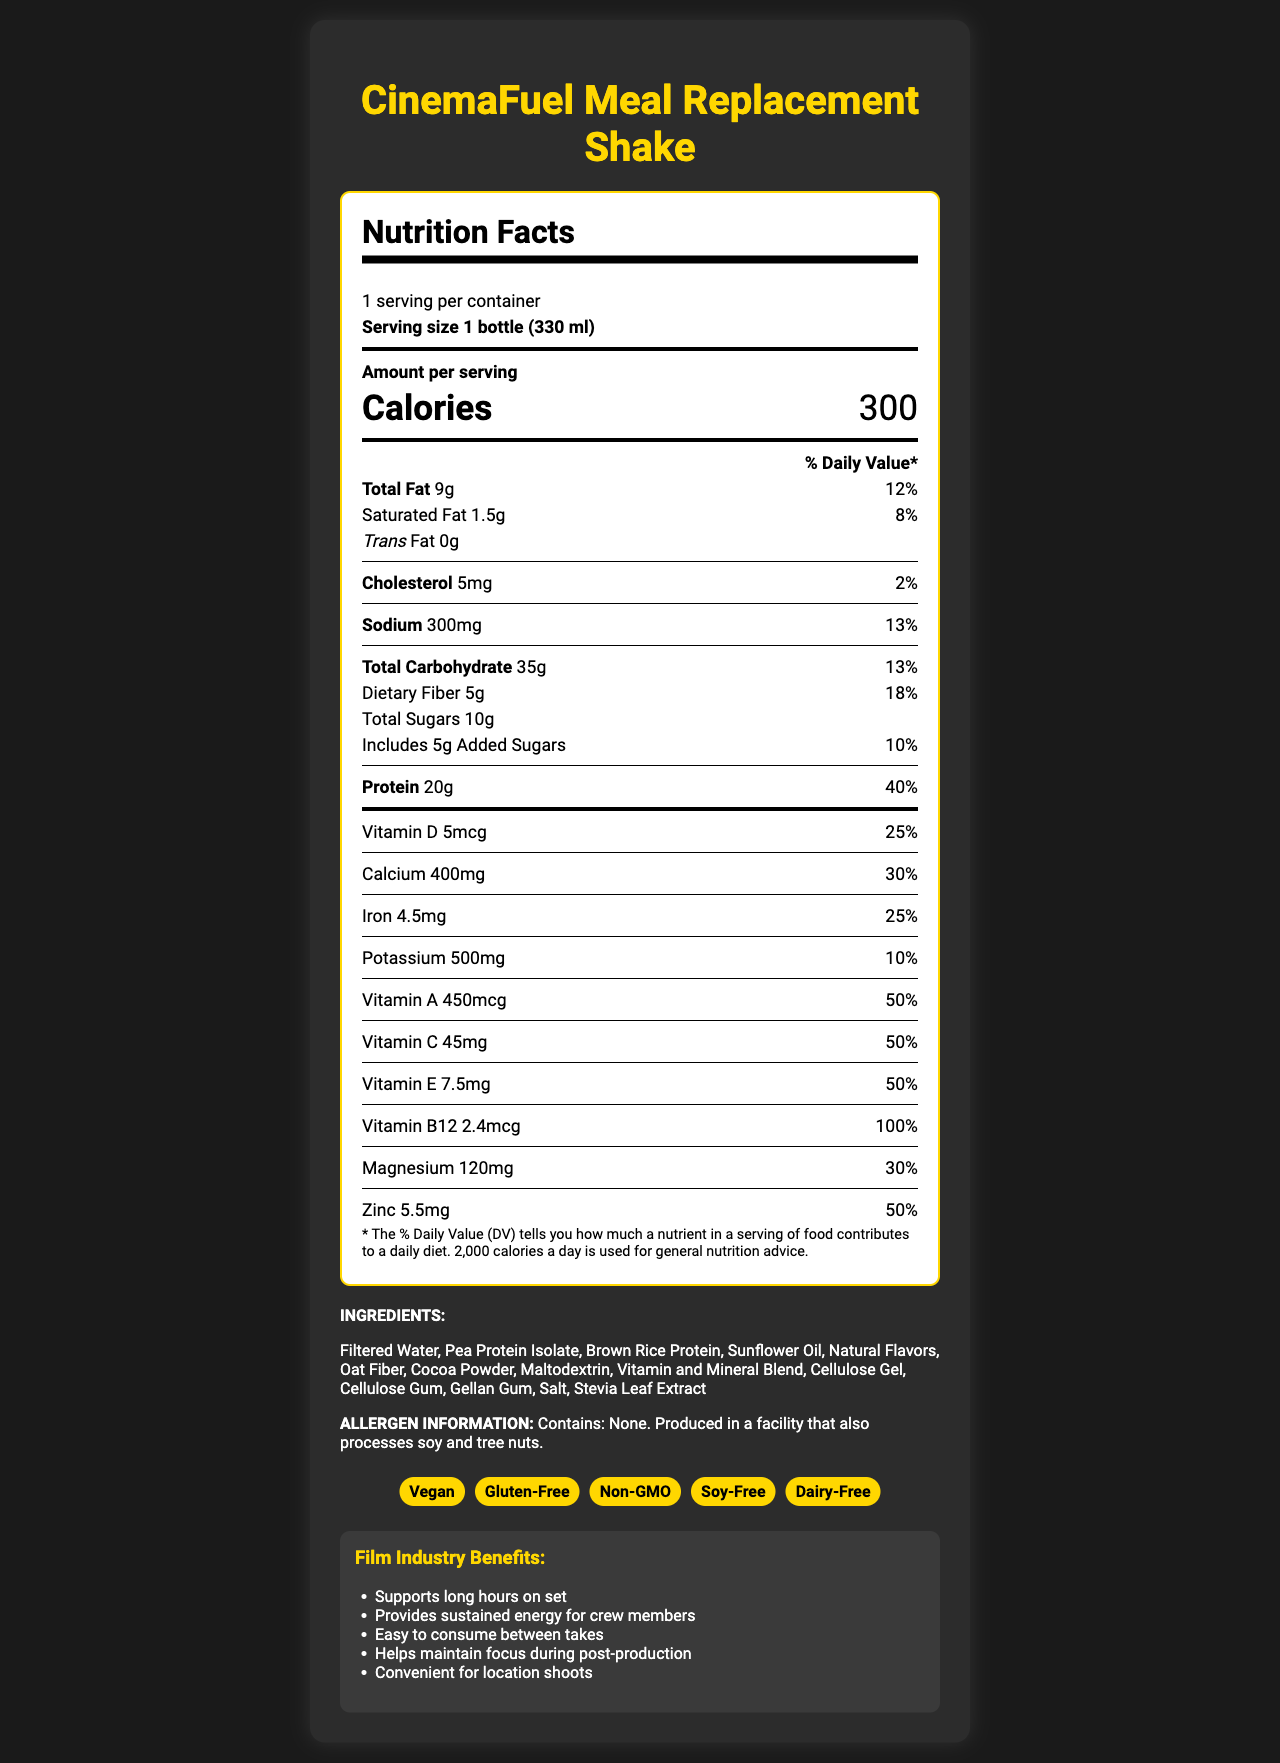what is the serving size for CinemaFuel Meal Replacement Shake? The document states the serving size as "1 bottle (330 ml)".
Answer: 1 bottle (330 ml) how many calories are there in one serving? The number of calories per serving is listed as 300.
Answer: 300 what is the total fat content and its daily percentage value? The total fat content is 9 grams, which corresponds to 12% of the Daily Value.
Answer: 9g, 12% how much protein does this shake provide? The document states that the shake provides 20 grams of protein.
Answer: 20g list three ingredients in the CinemaFuel Meal Replacement Shake. Among the ingredients listed are Filtered Water, Pea Protein Isolate, and Brown Rice Protein.
Answer: Filtered Water, Pea Protein Isolate, Brown Rice Protein what is the daily percentage value of vitamin B12? The document shows that Vitamin B12 provides 100% of the Daily Value per serving.
Answer: 100% what claim(s) do(es) the product make? The product claims to be Vegan, Gluten-Free, Non-GMO, Soy-Free, and Dairy-Free.
Answer: Vegan, Gluten-Free, Non-GMO, Soy-Free, Dairy-Free which of the following vitamins has the highest daily value percentage? A. Vitamin D B. Vitamin C C. Vitamin B12 D. Vitamin A The daily value percentage for Vitamin B12 is 100%, which is the highest compared to others listed.
Answer: C. Vitamin B12 how much dietary fiber does one serving contain? A. 5g B. 10g C. 20g D. 1.5g One serving contains 5 grams of dietary fiber.
Answer: A. 5g does the CinemaFuel Meal Replacement Shake contain cholesterol? The document states the drink contains 5mg of cholesterol.
Answer: Yes is this product allergen-free? Although the product itself contains no allergens, it is produced in a facility that processes soy and tree nuts.
Answer: No summarize the benefits of CinemaFuel Meal Replacement Shake for film industry professionals. The shake supports long hours on set, provides sustained energy, is easy to consume, helps maintain focus, and is convenient for location shoots, which makes it beneficial for film industry professionals.
Answer: Supports long hours on set, Provides sustained energy for crew members, Easy to consume between takes, Helps maintain focus during post-production, Convenient for location shoots what is the cost of one bottle of CinemaFuel? There is no information regarding the cost of one bottle in the document.
Answer: Cannot be determined 